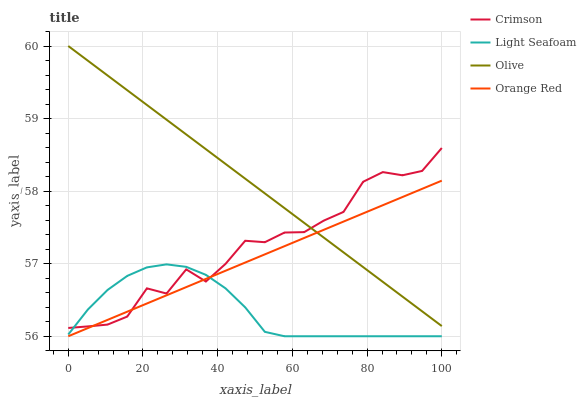Does Light Seafoam have the minimum area under the curve?
Answer yes or no. Yes. Does Olive have the maximum area under the curve?
Answer yes or no. Yes. Does Olive have the minimum area under the curve?
Answer yes or no. No. Does Light Seafoam have the maximum area under the curve?
Answer yes or no. No. Is Olive the smoothest?
Answer yes or no. Yes. Is Crimson the roughest?
Answer yes or no. Yes. Is Light Seafoam the smoothest?
Answer yes or no. No. Is Light Seafoam the roughest?
Answer yes or no. No. Does Light Seafoam have the lowest value?
Answer yes or no. Yes. Does Olive have the lowest value?
Answer yes or no. No. Does Olive have the highest value?
Answer yes or no. Yes. Does Light Seafoam have the highest value?
Answer yes or no. No. Is Light Seafoam less than Olive?
Answer yes or no. Yes. Is Olive greater than Light Seafoam?
Answer yes or no. Yes. Does Light Seafoam intersect Crimson?
Answer yes or no. Yes. Is Light Seafoam less than Crimson?
Answer yes or no. No. Is Light Seafoam greater than Crimson?
Answer yes or no. No. Does Light Seafoam intersect Olive?
Answer yes or no. No. 